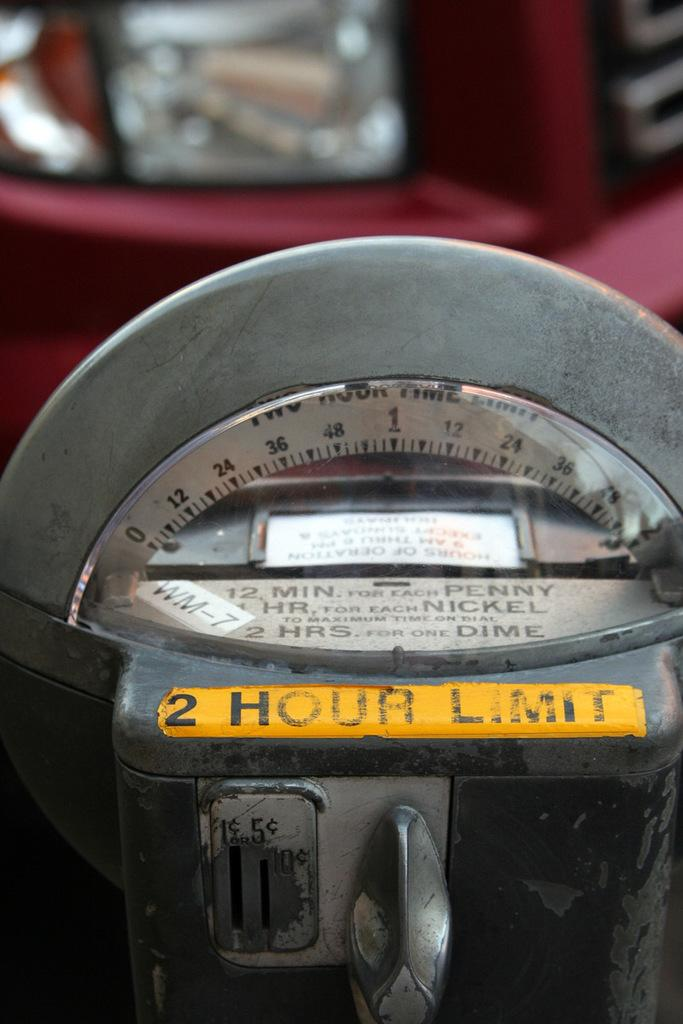<image>
Present a compact description of the photo's key features. a parking meter with a 2 hour limit. 